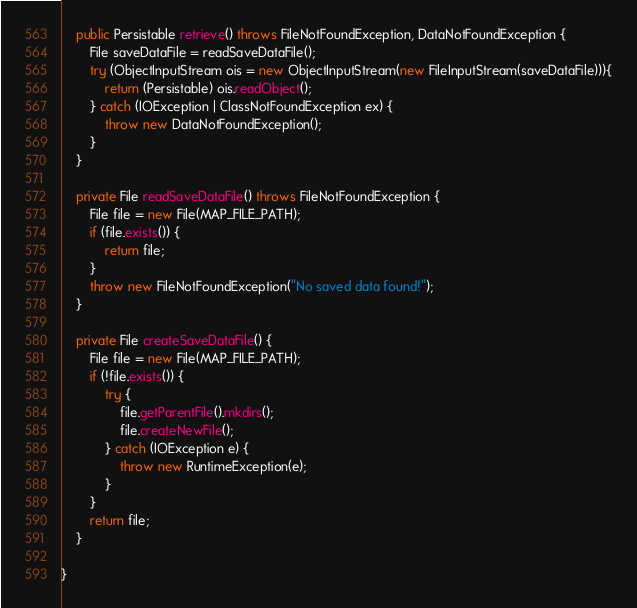Convert code to text. <code><loc_0><loc_0><loc_500><loc_500><_Java_>    public Persistable retrieve() throws FileNotFoundException, DataNotFoundException {
        File saveDataFile = readSaveDataFile();
        try (ObjectInputStream ois = new ObjectInputStream(new FileInputStream(saveDataFile))){
            return (Persistable) ois.readObject();
        } catch (IOException | ClassNotFoundException ex) {
            throw new DataNotFoundException();
        }
    }

    private File readSaveDataFile() throws FileNotFoundException {
        File file = new File(MAP_FILE_PATH);
        if (file.exists()) {
            return file;
        }
        throw new FileNotFoundException("No saved data found!");
    }

    private File createSaveDataFile() {
        File file = new File(MAP_FILE_PATH);
        if (!file.exists()) {
            try {
                file.getParentFile().mkdirs();
                file.createNewFile();
            } catch (IOException e) {
                throw new RuntimeException(e);
            }
        }
        return file;
    }

}
</code> 